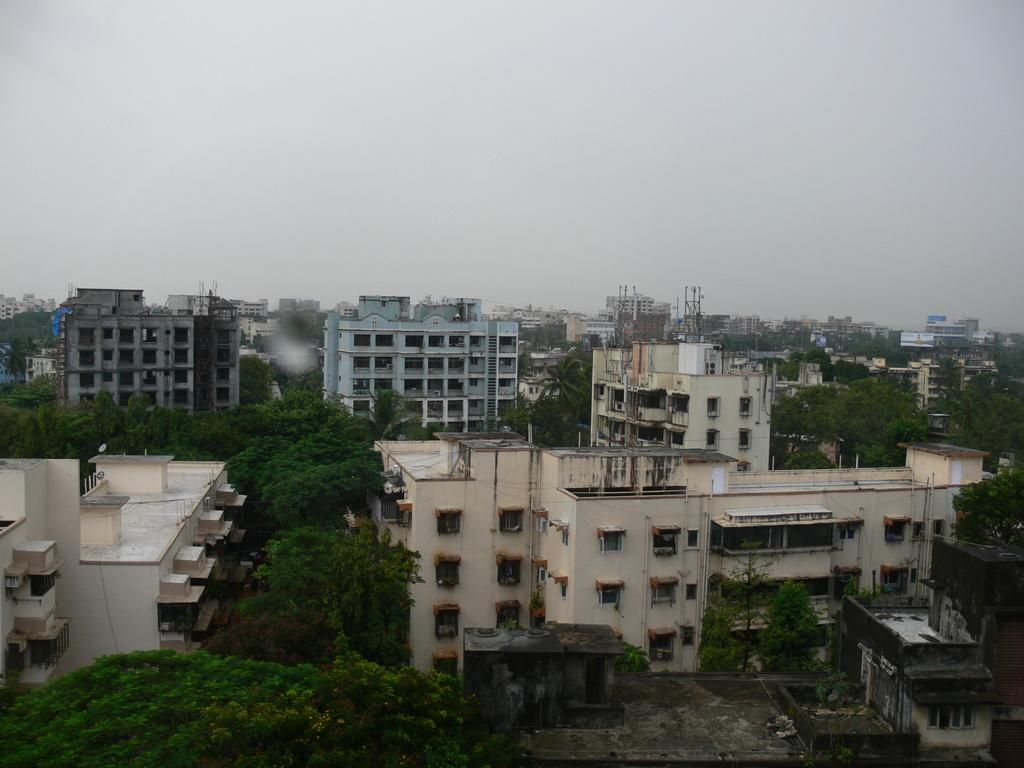What types of structures are visible in the image? There are buildings in the image. What type of vegetation can be seen in the image? There are trees in the image. How much sugar is present in the image? There is no sugar present in the image. What type of floor can be seen in the image? There is no floor visible in the image; it only shows buildings and trees. 